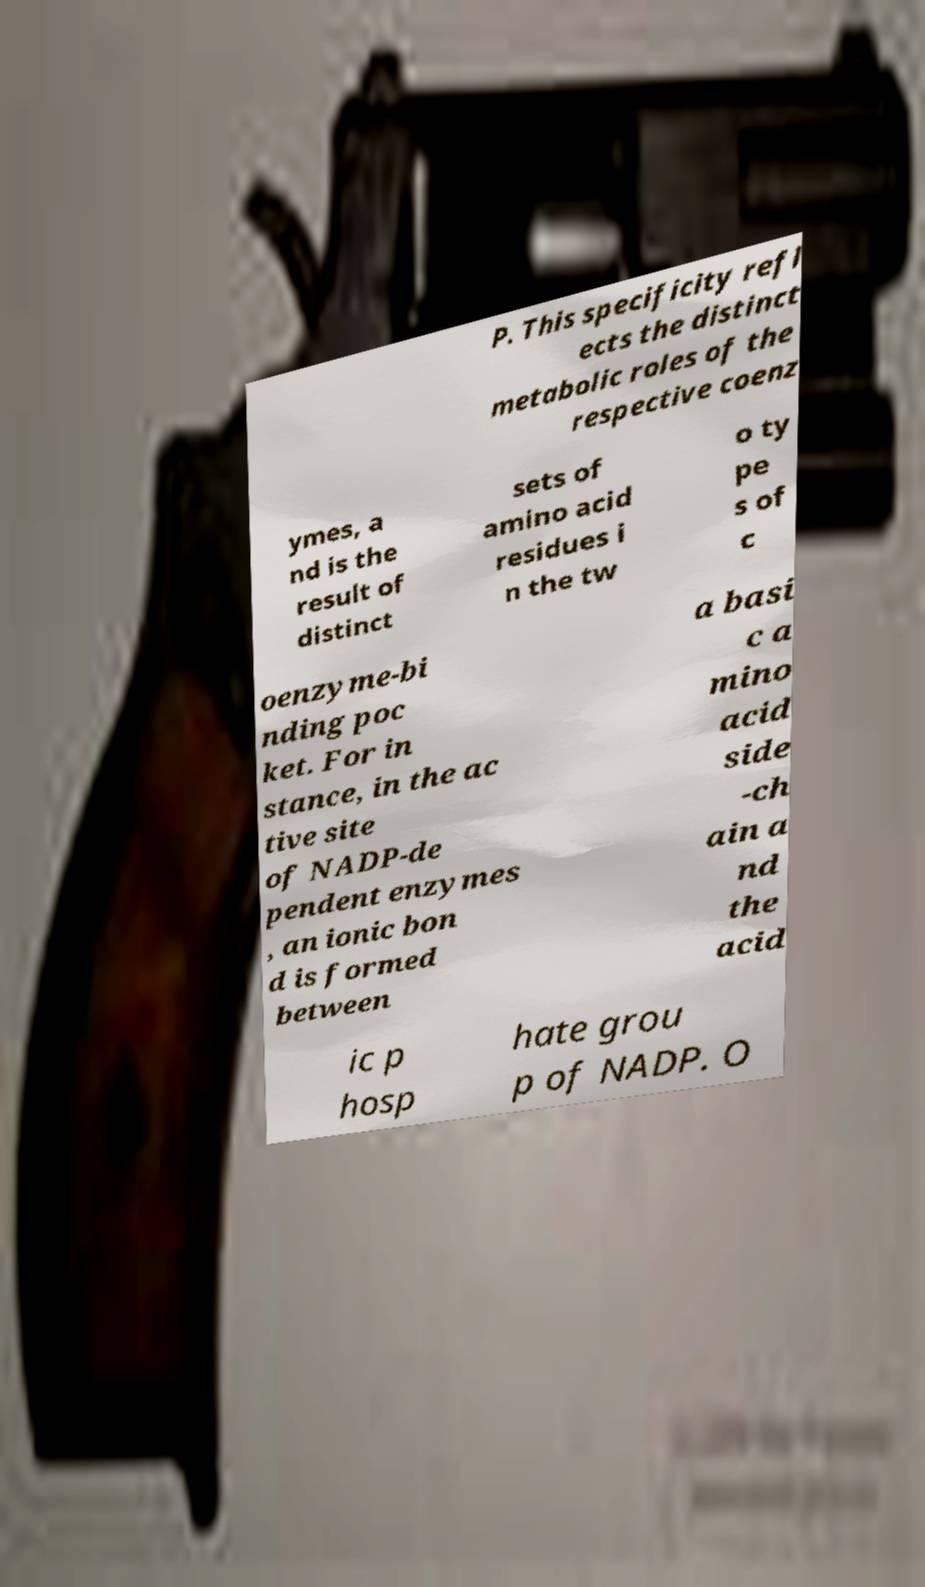Could you assist in decoding the text presented in this image and type it out clearly? P. This specificity refl ects the distinct metabolic roles of the respective coenz ymes, a nd is the result of distinct sets of amino acid residues i n the tw o ty pe s of c oenzyme-bi nding poc ket. For in stance, in the ac tive site of NADP-de pendent enzymes , an ionic bon d is formed between a basi c a mino acid side -ch ain a nd the acid ic p hosp hate grou p of NADP. O 